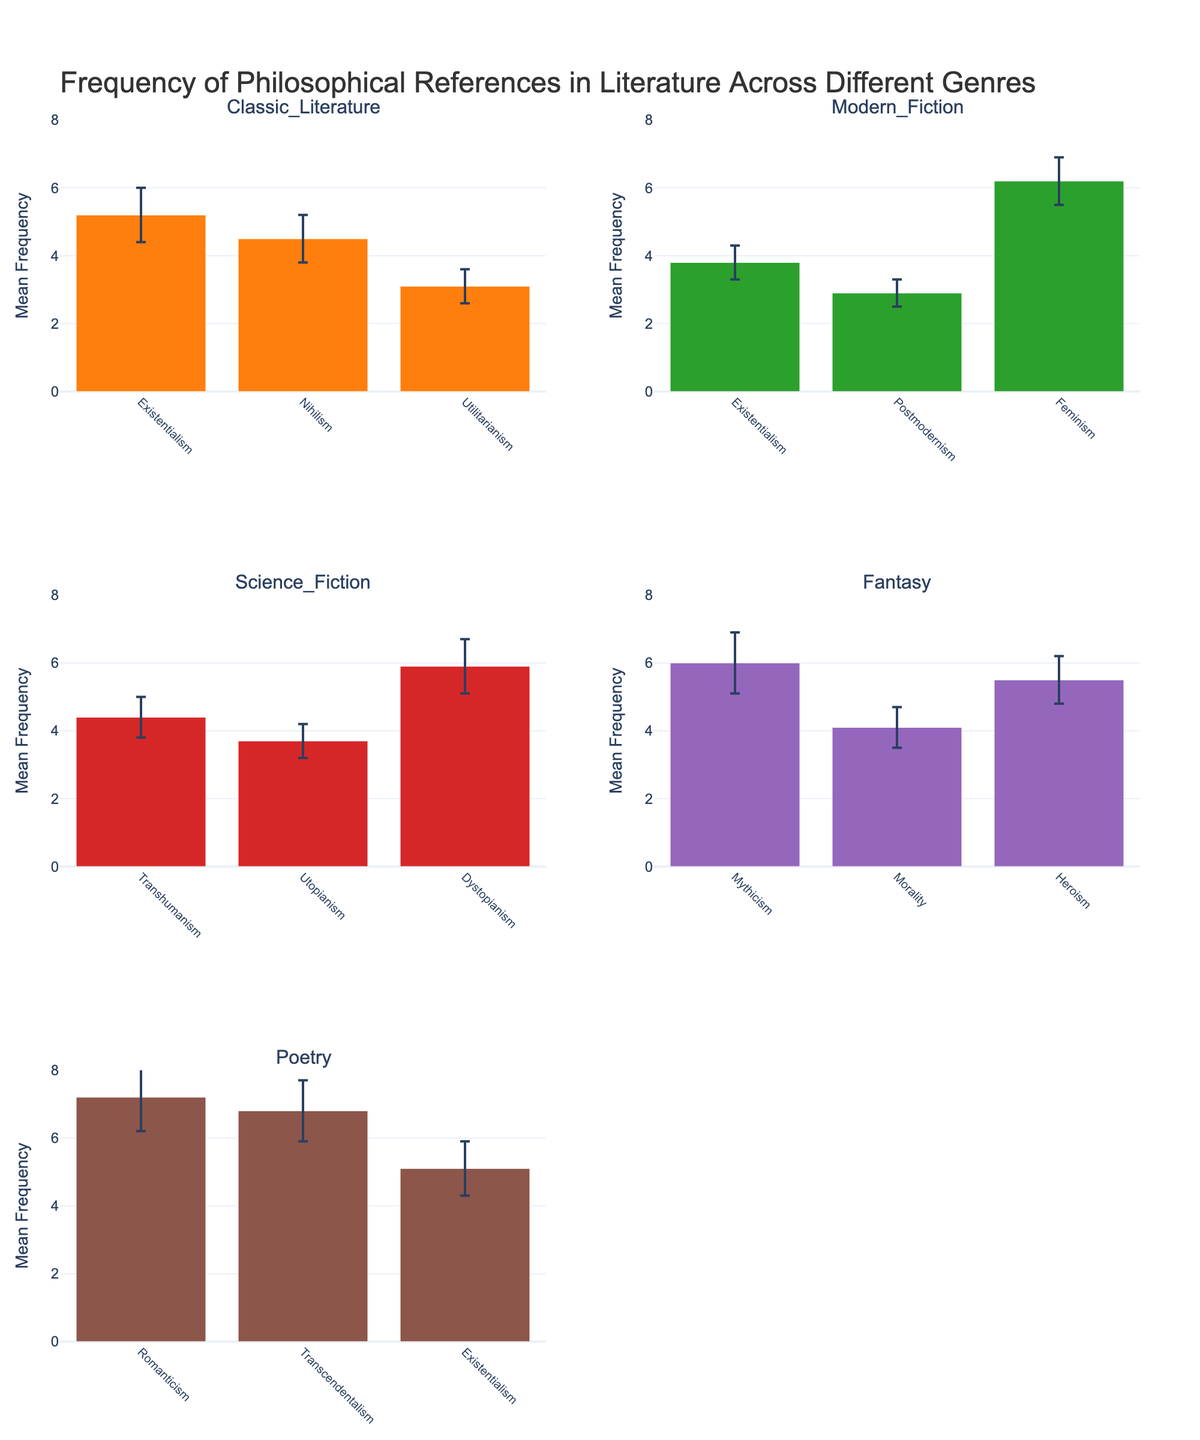what's the title of the figure? The title of the figure is usually displayed at the top. In this case, it reads, "Frequency of Philosophical References in Literature Across Different Genres."
Answer: Frequency of Philosophical References in Literature Across Different Genres how many genres are presented in the figure? There are six subplots, each corresponding to a different genre. These genres are Classic Literature, Modern Fiction, Science Fiction, Fantasy, and Poetry.
Answer: 5 which genre has the highest mean frequency of any philosophical reference? We need to look for the bar with the greatest height across all subplots to identify the greatest mean frequency. In Poetry, Romanticism shows a mean frequency of 7.2, which is the highest.
Answer: Poetry which philosophical reference in Science Fiction has the greatest mean frequency? In the Science Fiction subplot, Dystopianism has the highest mean frequency, indicated by the tallest bar.
Answer: Dystopianism what's the mean frequency of Existentialism in Modern Fiction? In the Modern Fiction subplot, we look for the bar labeled Existentialism. Its mean frequency is shown as 3.8.
Answer: 3.8 how much higher is the frequency of Feminism in Modern Fiction compared to Postmodernism in the same genre? In Modern Fiction, Feminism has a mean frequency of 6.2 while Postmodernism has 2.9. Subtracting 2.9 from 6.2 yields the difference.
Answer: 3.3 which philosophical reference in Fantasy has the highest error value? In the Fantasy subplot, the philosophical reference with the tallest error bar is Mythicism, which has an error value of 0.9.
Answer: Mythicism what is the range of mean frequencies displayed on the y-axis? The y-axis is labeled 'Mean Frequency' and its range is from 0 to 8, as indicated by the axis ticks and limits.
Answer: 0 to 8 which two genres share Existentialism as a philosophical reference and what are their respective mean frequencies? Existentialism appears in Classic Literature and Modern Fiction. Classic Literature shows a mean frequency of 5.2, and Modern Fiction shows a mean frequency of 3.8.
Answer: Classic Literature: 5.2, Modern Fiction: 3.8 